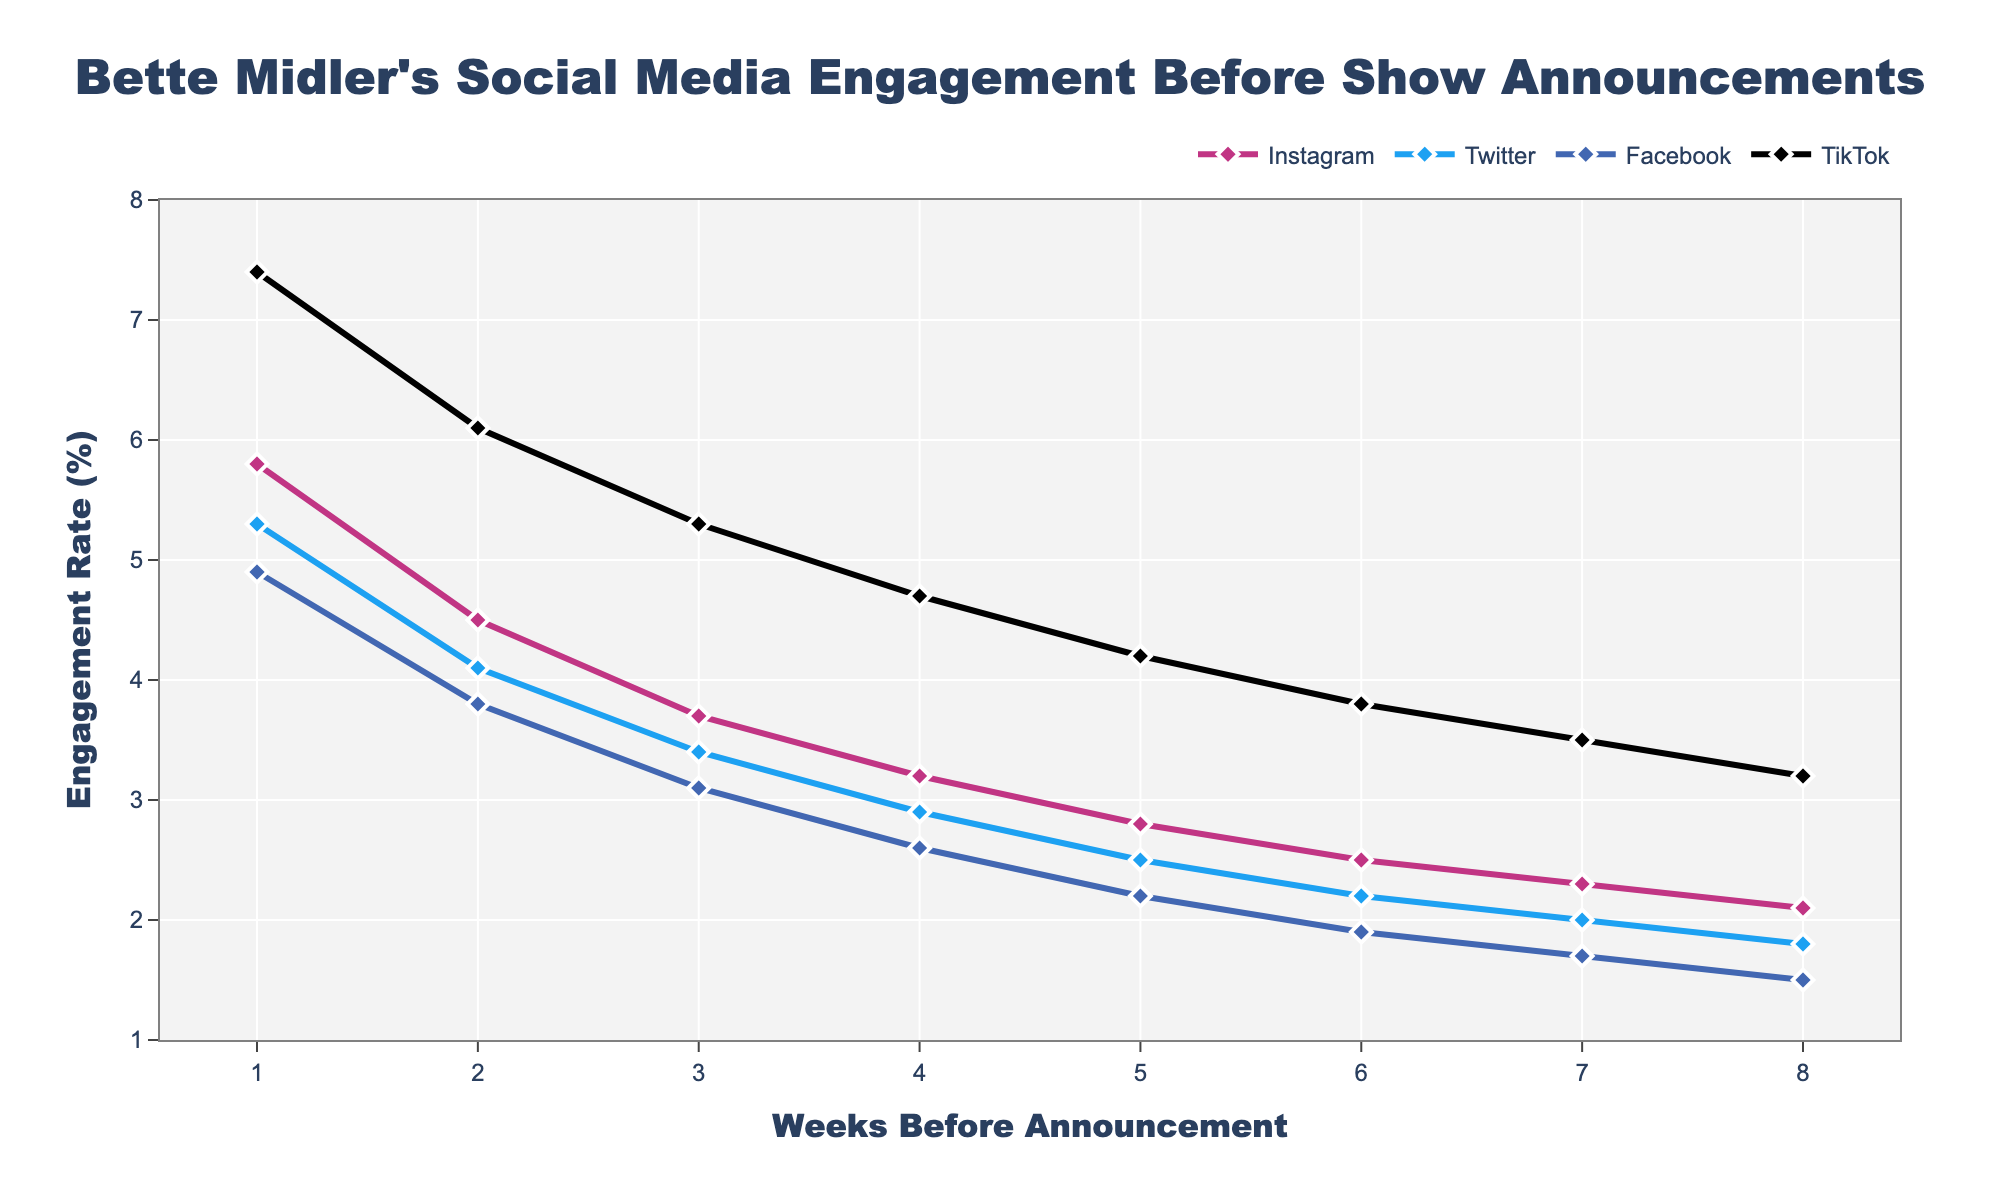What is the engagement rate on TikTok 1 week before the announcement? To find this, look for the TikTok data point where the "Weeks Before Announcement" is 1. The engagement rate for TikTok at this point is 7.4%.
Answer: 7.4% Compare the engagement rates of Instagram and Twitter 4 weeks before the announcement. Which one is higher? Look at the engagement rate for both Instagram and Twitter at the "Weeks Before Announcement" of 4. Instagram’s engagement rate is 3.2%, while Twitter’s is 2.9%. Instagram's rate is higher.
Answer: Instagram What is the difference in engagement rates between TikTok and Facebook 2 weeks before the announcement? For TikTok, the engagement rate at "Weeks Before Announcement" of 2 is 6.1%. For Facebook, it is 3.8%. The difference is 6.1% - 3.8% = 2.3%.
Answer: 2.3% Calculate the average engagement rate on Twitter over the 8 weeks before the announcement. Sum all the engagement rates for Twitter: 1.8 + 2.0 + 2.2 + 2.5 + 2.9 + 3.4 + 4.1 + 5.3 = 24.2. Divide by the number of weeks, which is 8. The average engagement rate is 24.2 / 8 = 3.025%.
Answer: 3.025% What is the general trend in engagement rates on Facebook as the announcement date approaches? Observe the engagement rates for Facebook over successive weeks. The values increase from 1.5% to 4.9%, showing a clear upward trend.
Answer: Upward trend By how much does Instagram’s engagement rate increase from 3 weeks to 1 week before the announcement? Instagram’s engagement rate at 3 weeks is 3.7%, and at 1 week it is 5.8%. The increase is 5.8% - 3.7% = 2.1%.
Answer: 2.1% What is the color representation used for Twitter in the plot? Refer to the color-coded lines and markers in the plot. Twitter is represented in blue.
Answer: Blue 